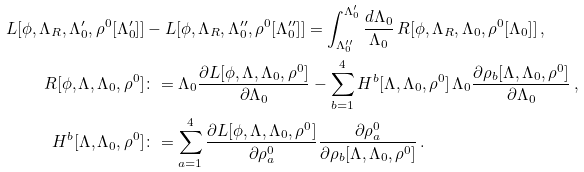<formula> <loc_0><loc_0><loc_500><loc_500>L [ \phi , \Lambda _ { R } , \Lambda _ { 0 } ^ { \prime } , \rho ^ { 0 } [ \Lambda _ { 0 } ^ { \prime } ] ] & - L [ \phi , \Lambda _ { R } , \Lambda _ { 0 } ^ { \prime \prime } , \rho ^ { 0 } [ \Lambda _ { 0 } ^ { \prime \prime } ] ] = \int _ { \Lambda _ { 0 } ^ { \prime \prime } } ^ { \Lambda _ { 0 } ^ { \prime } } \frac { d \Lambda _ { 0 } } { \Lambda _ { 0 } } \, R [ \phi , \Lambda _ { R } , \Lambda _ { 0 } , \rho ^ { 0 } [ \Lambda _ { 0 } ] ] \, , \\ R [ \phi , \Lambda , \Lambda _ { 0 } , \rho ^ { 0 } ] & \colon = \Lambda _ { 0 } \frac { \partial L [ \phi , \Lambda , \Lambda _ { 0 } , \rho ^ { 0 } ] } { \partial \Lambda _ { 0 } } - \sum _ { b = 1 } ^ { 4 } H ^ { b } [ \Lambda , \Lambda _ { 0 } , \rho ^ { 0 } ] \, \Lambda _ { 0 } \frac { \partial \rho _ { b } [ \Lambda , \Lambda _ { 0 } , \rho ^ { 0 } ] } { \partial \Lambda _ { 0 } } \, , \\ H ^ { b } [ \Lambda , \Lambda _ { 0 } , \rho ^ { 0 } ] & \colon = \sum _ { a = 1 } ^ { 4 } \frac { \partial L [ \phi , \Lambda , \Lambda _ { 0 } , \rho ^ { 0 } ] } { \partial \rho _ { a } ^ { 0 } } \frac { \partial \rho _ { a } ^ { 0 } } { \partial \rho _ { b } [ \Lambda , \Lambda _ { 0 } , \rho ^ { 0 } ] } \, .</formula> 